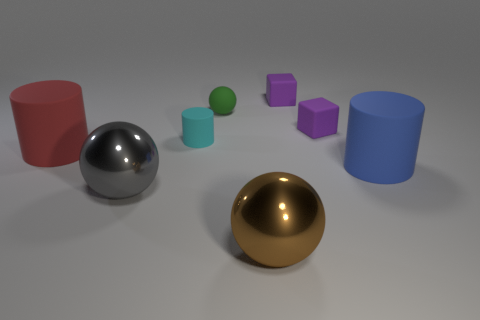Add 1 large purple shiny objects. How many objects exist? 9 Subtract all cylinders. How many objects are left? 5 Subtract 0 brown blocks. How many objects are left? 8 Subtract all large things. Subtract all red cylinders. How many objects are left? 3 Add 7 gray shiny spheres. How many gray shiny spheres are left? 8 Add 5 balls. How many balls exist? 8 